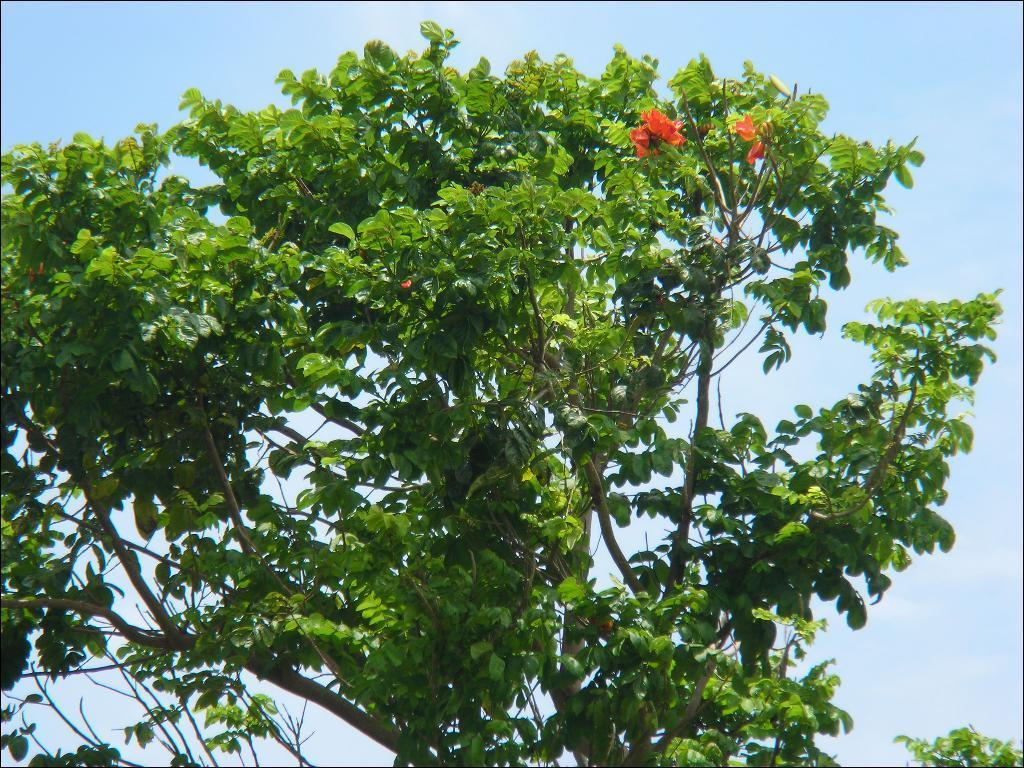What is the main subject of the picture? The main subject of the picture is a tree with many leaves. What can be seen in the background of the picture? The sky is visible behind the tree in the picture. How many cows are grazing under the tree in the picture? There are no cows present in the image; it only features a tree with many leaves and the sky in the background. 